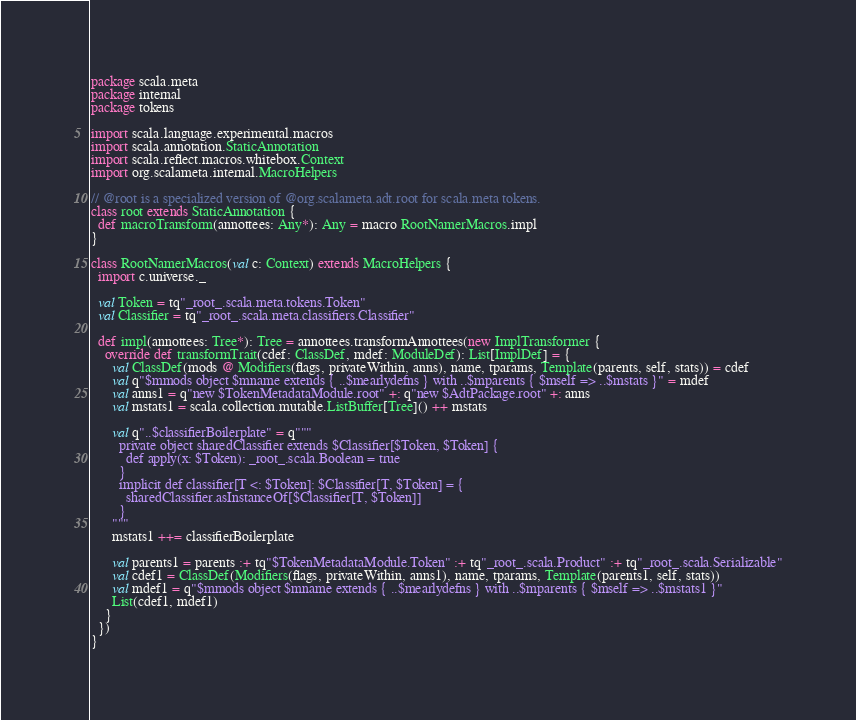Convert code to text. <code><loc_0><loc_0><loc_500><loc_500><_Scala_>package scala.meta
package internal
package tokens

import scala.language.experimental.macros
import scala.annotation.StaticAnnotation
import scala.reflect.macros.whitebox.Context
import org.scalameta.internal.MacroHelpers

// @root is a specialized version of @org.scalameta.adt.root for scala.meta tokens.
class root extends StaticAnnotation {
  def macroTransform(annottees: Any*): Any = macro RootNamerMacros.impl
}

class RootNamerMacros(val c: Context) extends MacroHelpers {
  import c.universe._

  val Token = tq"_root_.scala.meta.tokens.Token"
  val Classifier = tq"_root_.scala.meta.classifiers.Classifier"

  def impl(annottees: Tree*): Tree = annottees.transformAnnottees(new ImplTransformer {
    override def transformTrait(cdef: ClassDef, mdef: ModuleDef): List[ImplDef] = {
      val ClassDef(mods @ Modifiers(flags, privateWithin, anns), name, tparams, Template(parents, self, stats)) = cdef
      val q"$mmods object $mname extends { ..$mearlydefns } with ..$mparents { $mself => ..$mstats }" = mdef
      val anns1 = q"new $TokenMetadataModule.root" +: q"new $AdtPackage.root" +: anns
      val mstats1 = scala.collection.mutable.ListBuffer[Tree]() ++ mstats

      val q"..$classifierBoilerplate" = q"""
        private object sharedClassifier extends $Classifier[$Token, $Token] {
          def apply(x: $Token): _root_.scala.Boolean = true
        }
        implicit def classifier[T <: $Token]: $Classifier[T, $Token] = {
          sharedClassifier.asInstanceOf[$Classifier[T, $Token]]
        }
      """
      mstats1 ++= classifierBoilerplate

      val parents1 = parents :+ tq"$TokenMetadataModule.Token" :+ tq"_root_.scala.Product" :+ tq"_root_.scala.Serializable"
      val cdef1 = ClassDef(Modifiers(flags, privateWithin, anns1), name, tparams, Template(parents1, self, stats))
      val mdef1 = q"$mmods object $mname extends { ..$mearlydefns } with ..$mparents { $mself => ..$mstats1 }"
      List(cdef1, mdef1)
    }
  })
}
</code> 